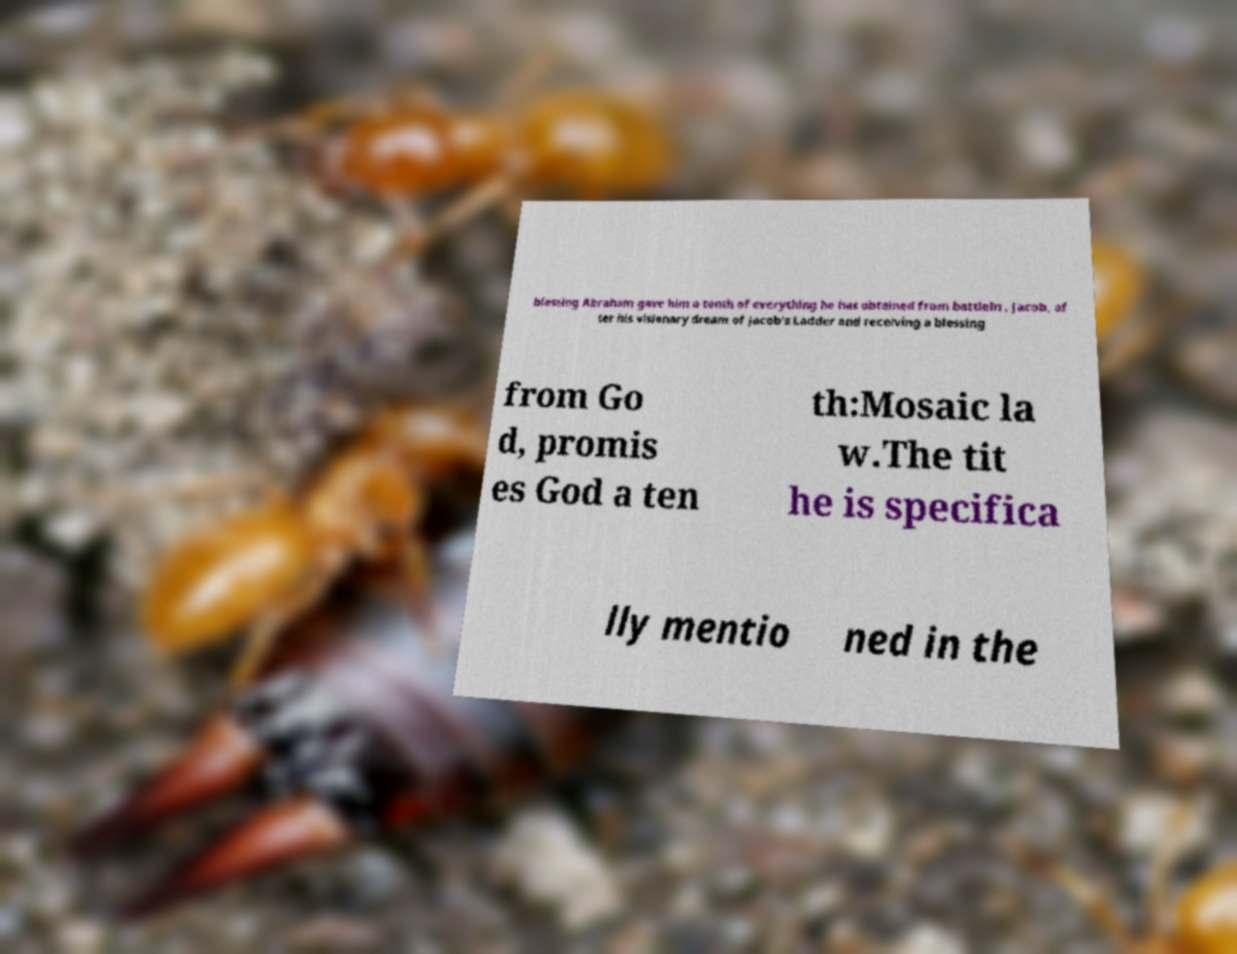Please read and relay the text visible in this image. What does it say? blessing Abraham gave him a tenth of everything he has obtained from battleIn , Jacob, af ter his visionary dream of Jacob's Ladder and receiving a blessing from Go d, promis es God a ten th:Mosaic la w.The tit he is specifica lly mentio ned in the 